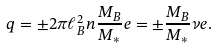Convert formula to latex. <formula><loc_0><loc_0><loc_500><loc_500>q = \pm 2 \pi \ell _ { B } ^ { 2 } n \frac { M _ { B } } { M _ { * } } e = \pm \frac { M _ { B } } { M _ { * } } \nu e .</formula> 